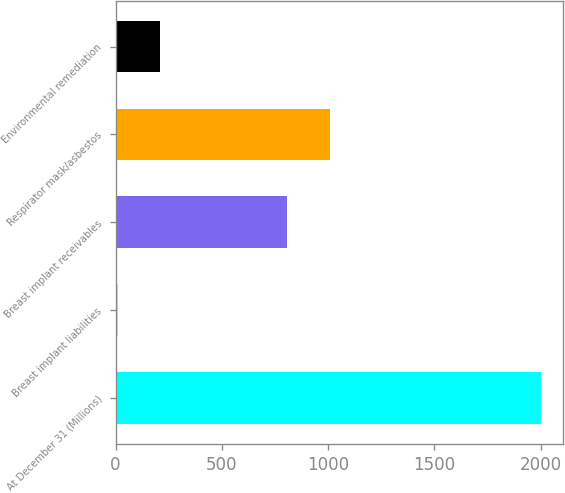<chart> <loc_0><loc_0><loc_500><loc_500><bar_chart><fcel>At December 31 (Millions)<fcel>Breast implant liabilities<fcel>Breast implant receivables<fcel>Respirator mask/asbestos<fcel>Environmental remediation<nl><fcel>2004<fcel>11<fcel>808.2<fcel>1007.5<fcel>210.3<nl></chart> 